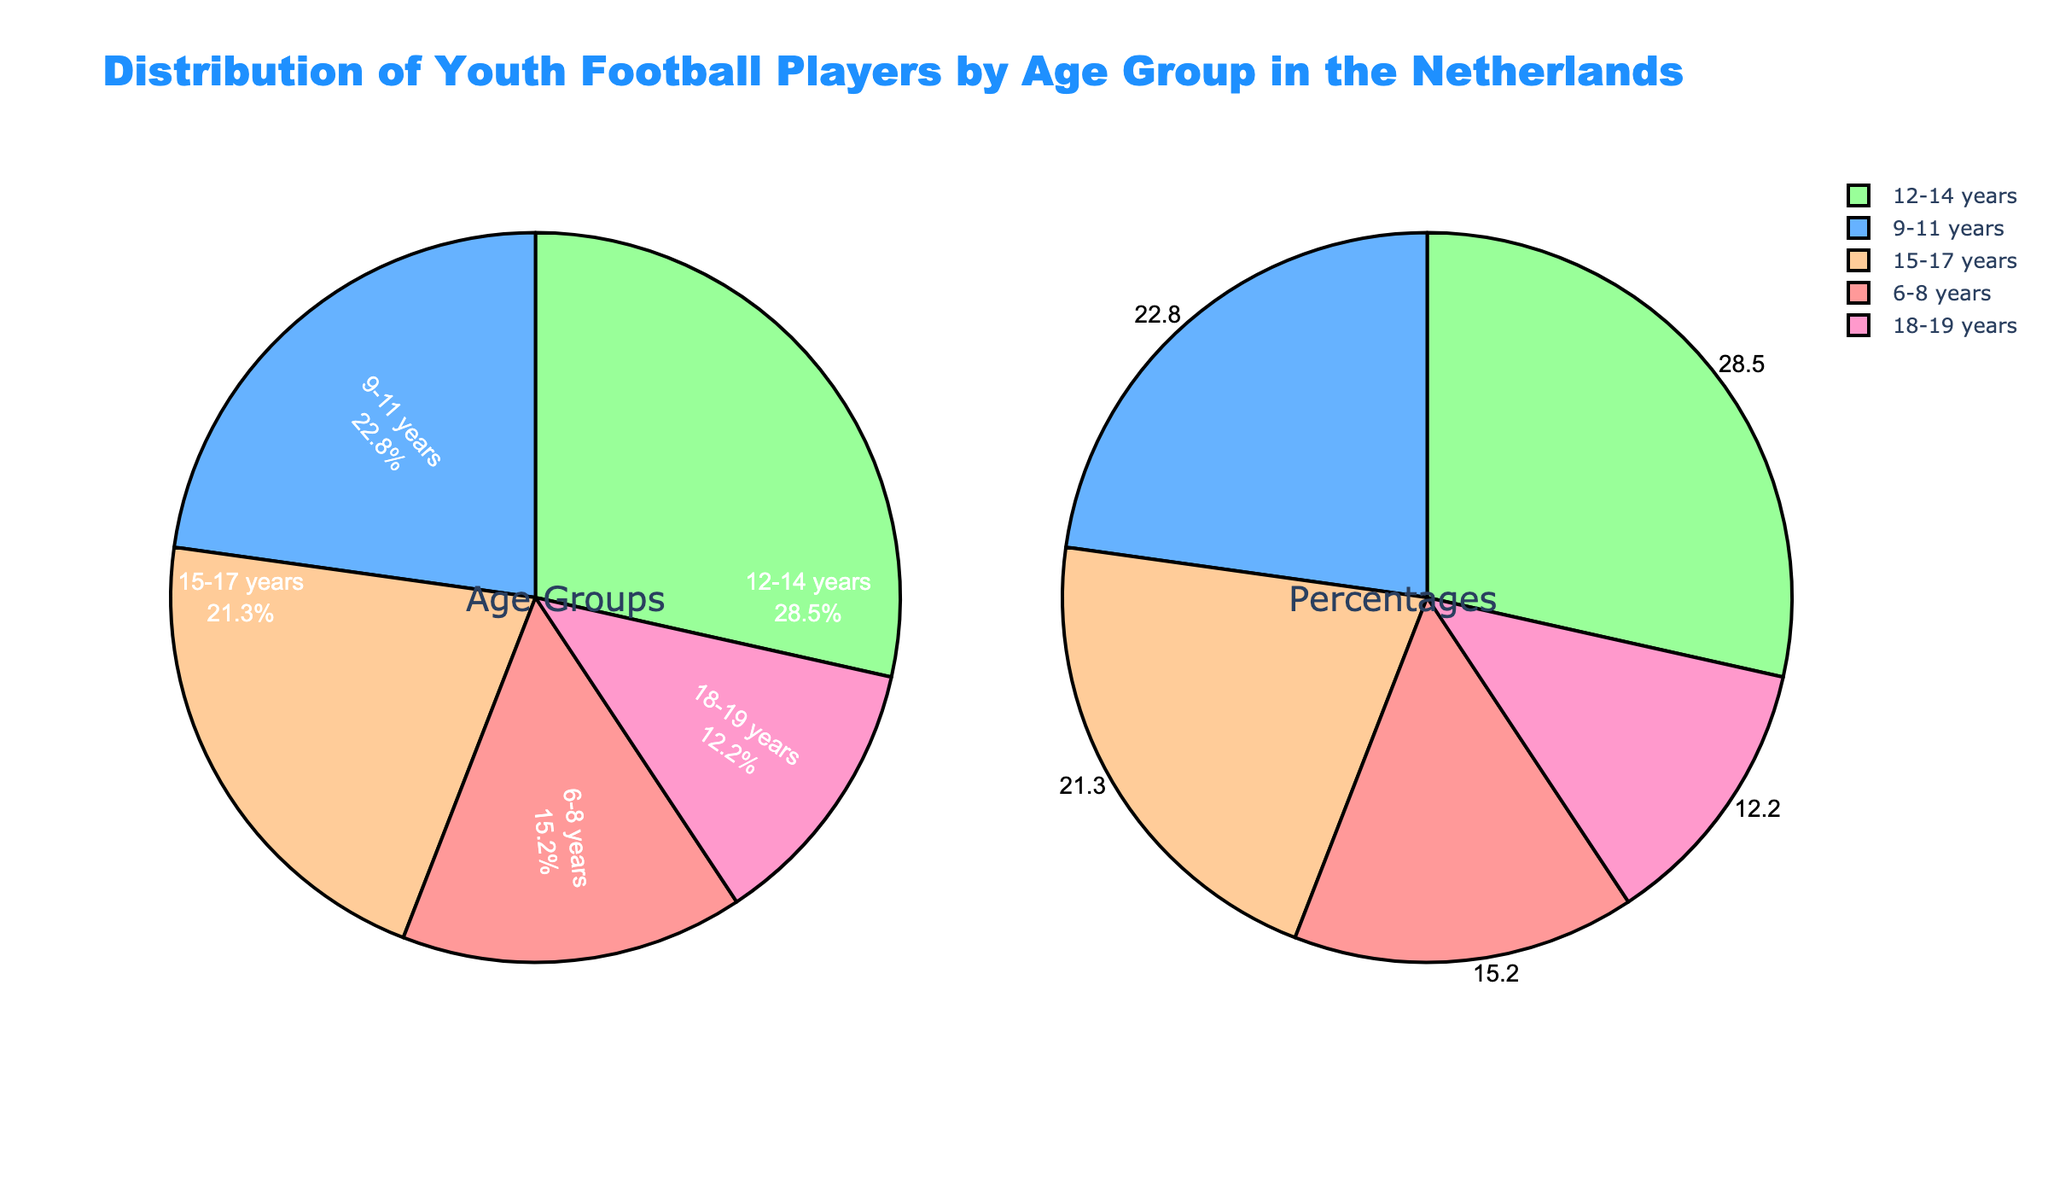What percentage of youth football players are in the age group 12-14 years? Look at the corresponding slice of the pie chart for the age group 12-14 years and read the percentage value displayed.
Answer: 28.5% Which age group has the smallest percentage of youth football players? Compare all the percentage values displayed for each age group and identify the smallest one.
Answer: 18-19 years How much larger is the percentage of players in the 9-11 years group compared to the 6-8 years group? Subtract the percentage of the 6-8 years group from the percentage of the 9-11 years group: 22.8 - 15.2 = 7.6
Answer: 7.6 What is the combined percentage of youth football players in the age groups 15-17 years and 18-19 years? Add the percentage values of the 15-17 years and 18-19 years age groups: 21.3 + 12.2 = 33.5
Answer: 33.5 Which age group has a greater percentage of players, 15-17 years or 6-8 years? Compare the percentages of the two age groups: 21.3 (15-17 years) and 15.2 (6-8 years).
Answer: 15-17 years If you combine the 6-8 years and 9-11 years age groups, what percentage of the total player population do they represent? Add the percentages of the 6-8 years and 9-11 years age groups: 15.2 + 22.8 = 38
Answer: 38 How much smaller is the percentage of players in the 18-19 years group compared to the 12-14 years group? Subtract the percentage of the 18-19 years group from the percentage of the 12-14 years group: 28.5 - 12.2 = 16.3
Answer: 16.3 What is the difference in percentage between the largest and smallest age groups? Find the difference between 28.5% (largest - 12-14 years) and 12.2% (smallest - 18-19 years): 28.5 - 12.2 = 16.3
Answer: 16.3 